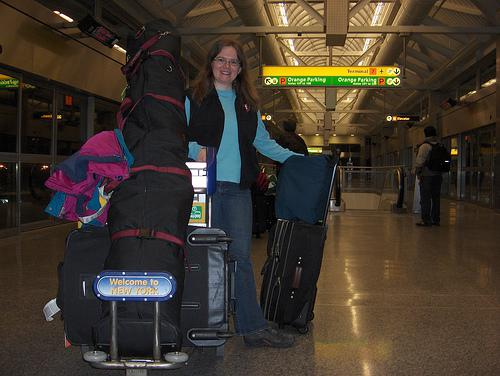Question: why does the woman have a cart?
Choices:
A. Needs groceries.
B. Much luggage.
C. In shopper's club.
D. Buying bulky item.
Answer with the letter. Answer: B Question: where is the escalator?
Choices:
A. Behind the garbage bin.
B. To the side of the newspaper stand.
C. In front of the man.
D. To the side of the information booth.
Answer with the letter. Answer: C Question: when is the picture taken?
Choices:
A. Day.
B. Night.
C. Afternoon.
D. Morning.
Answer with the letter. Answer: B Question: who is touching the luggage?
Choices:
A. A porter.
B. Police officer.
C. A woman.
D. Airport handler.
Answer with the letter. Answer: C Question: what is the woman wearing?
Choices:
A. Blouse and skirt.
B. Dress and sandals.
C. T-Shirt and shorts.
D. Shirt and pants.
Answer with the letter. Answer: D Question: what is the location?
Choices:
A. Sport stadium.
B. City intersection.
C. Highway.
D. Transportation terminal.
Answer with the letter. Answer: D 